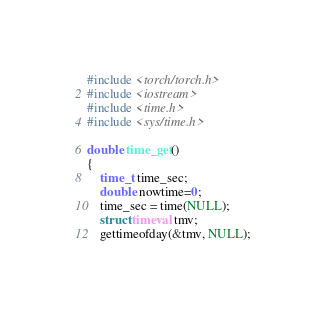<code> <loc_0><loc_0><loc_500><loc_500><_C++_>#include <torch/torch.h>
#include <iostream>
#include <time.h>
#include <sys/time.h>

double time_get()
{
    time_t time_sec;
    double nowtime=0;
    time_sec = time(NULL);
    struct timeval tmv;
    gettimeofday(&tmv, NULL);</code> 